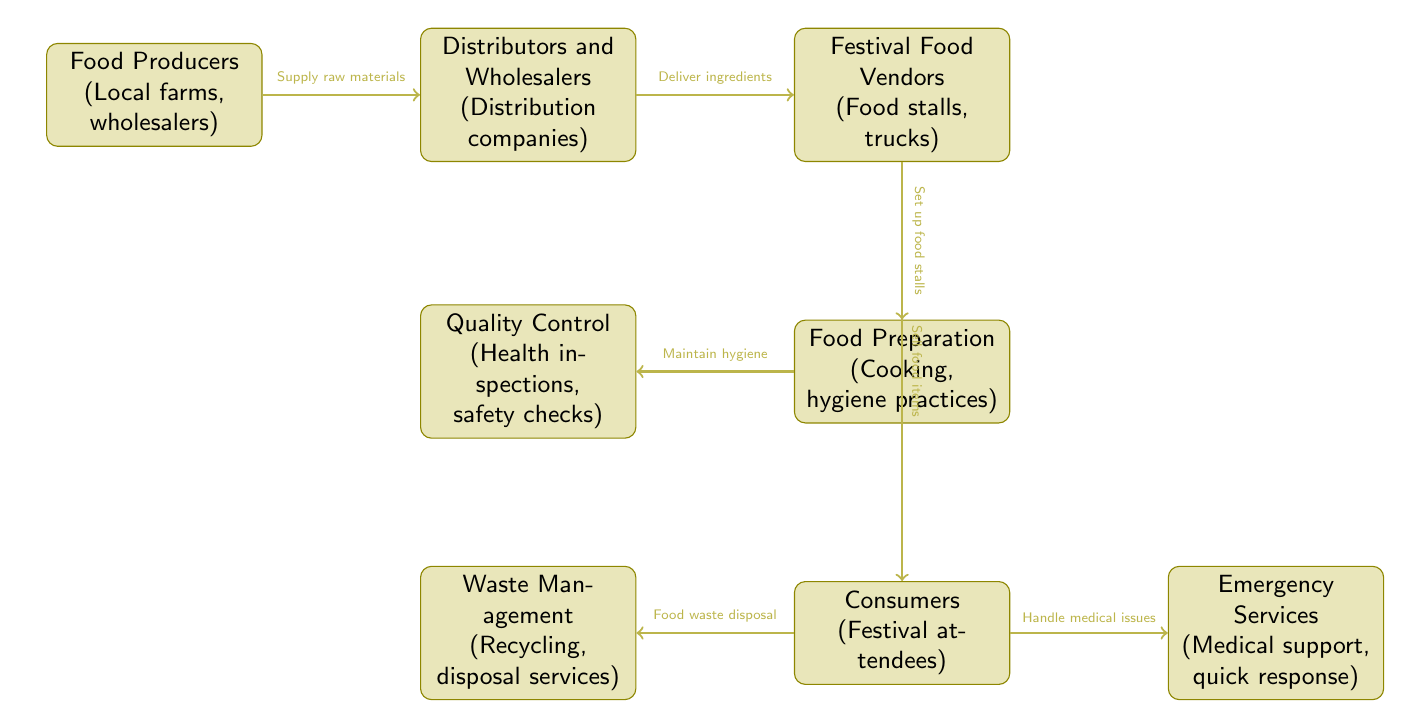What is the starting point of the food chain? The food chain starts with the "Food Producers" node, indicating that local farms and wholesalers supply the raw materials.
Answer: Food Producers How many nodes are in the diagram? Counting all the distinct points, there are eight nodes in the diagram that represent different stages of the food chain.
Answer: 8 What role do vendors play in the food chain? Vendors are responsible for setting up food stalls and selling food items to the consumers at the festival.
Answer: Festival Food Vendors What is the function of quality control in the food chain? Quality control performs health inspections and safety checks to ensure that food served at the festival is safe for consumption.
Answer: Health inspections, safety checks Which node is directly connected to both consumers and waste management? The "Consumers" node has direct connections leading out to both "Waste Management" and "Emergency Services."
Answer: Consumers How does food get from producers to vendors? Food travels from producers to vendors through distributors and wholesalers who deliver ingredients to them.
Answer: Deliver ingredients What is the relationship between consumers and emergency services? Consumers have a relationship with emergency services as they handle any medical issues that arise during the festival, ensuring health and safety.
Answer: Handle medical issues What checks occur before food is served to consumers? Before food is served, food preparation must maintain hygiene, which is monitored by quality control practices.
Answer: Maintain hygiene Who handles food waste disposal? The "Waste Management" node is responsible for the disposal and recycling of food waste generated by consumers during the festival.
Answer: Waste Management 